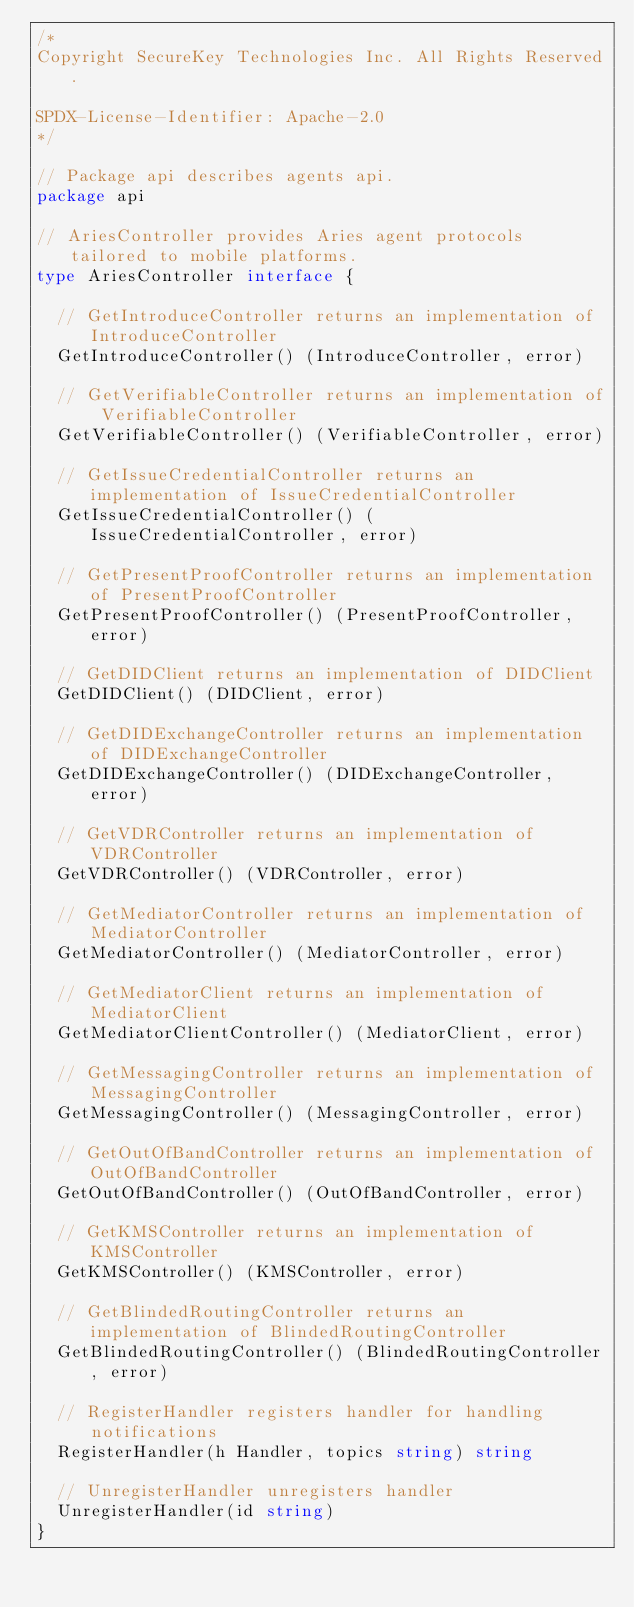Convert code to text. <code><loc_0><loc_0><loc_500><loc_500><_Go_>/*
Copyright SecureKey Technologies Inc. All Rights Reserved.

SPDX-License-Identifier: Apache-2.0
*/

// Package api describes agents api.
package api

// AriesController provides Aries agent protocols tailored to mobile platforms.
type AriesController interface {

	// GetIntroduceController returns an implementation of IntroduceController
	GetIntroduceController() (IntroduceController, error)

	// GetVerifiableController returns an implementation of VerifiableController
	GetVerifiableController() (VerifiableController, error)

	// GetIssueCredentialController returns an implementation of IssueCredentialController
	GetIssueCredentialController() (IssueCredentialController, error)

	// GetPresentProofController returns an implementation of PresentProofController
	GetPresentProofController() (PresentProofController, error)

	// GetDIDClient returns an implementation of DIDClient
	GetDIDClient() (DIDClient, error)

	// GetDIDExchangeController returns an implementation of DIDExchangeController
	GetDIDExchangeController() (DIDExchangeController, error)

	// GetVDRController returns an implementation of VDRController
	GetVDRController() (VDRController, error)

	// GetMediatorController returns an implementation of MediatorController
	GetMediatorController() (MediatorController, error)

	// GetMediatorClient returns an implementation of MediatorClient
	GetMediatorClientController() (MediatorClient, error)

	// GetMessagingController returns an implementation of MessagingController
	GetMessagingController() (MessagingController, error)

	// GetOutOfBandController returns an implementation of OutOfBandController
	GetOutOfBandController() (OutOfBandController, error)

	// GetKMSController returns an implementation of KMSController
	GetKMSController() (KMSController, error)

	// GetBlindedRoutingController returns an implementation of BlindedRoutingController
	GetBlindedRoutingController() (BlindedRoutingController, error)

	// RegisterHandler registers handler for handling notifications
	RegisterHandler(h Handler, topics string) string

	// UnregisterHandler unregisters handler
	UnregisterHandler(id string)
}
</code> 